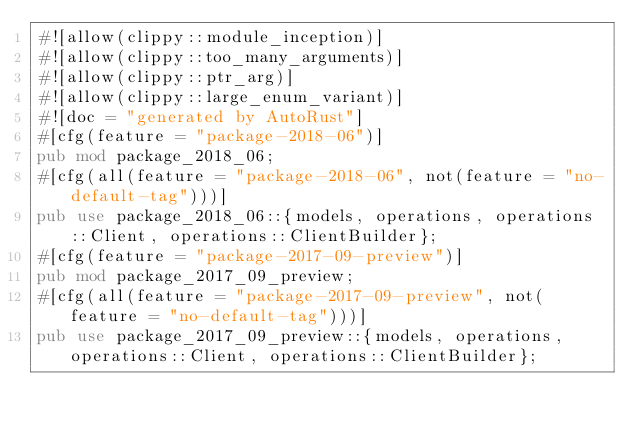<code> <loc_0><loc_0><loc_500><loc_500><_Rust_>#![allow(clippy::module_inception)]
#![allow(clippy::too_many_arguments)]
#![allow(clippy::ptr_arg)]
#![allow(clippy::large_enum_variant)]
#![doc = "generated by AutoRust"]
#[cfg(feature = "package-2018-06")]
pub mod package_2018_06;
#[cfg(all(feature = "package-2018-06", not(feature = "no-default-tag")))]
pub use package_2018_06::{models, operations, operations::Client, operations::ClientBuilder};
#[cfg(feature = "package-2017-09-preview")]
pub mod package_2017_09_preview;
#[cfg(all(feature = "package-2017-09-preview", not(feature = "no-default-tag")))]
pub use package_2017_09_preview::{models, operations, operations::Client, operations::ClientBuilder};
</code> 